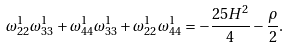<formula> <loc_0><loc_0><loc_500><loc_500>\omega _ { 2 2 } ^ { 1 } \omega _ { 3 3 } ^ { 1 } + \omega _ { 4 4 } ^ { 1 } \omega _ { 3 3 } ^ { 1 } + \omega _ { 2 2 } ^ { 1 } \omega _ { 4 4 } ^ { 1 } = - \frac { 2 5 H ^ { 2 } } { 4 } - \frac { \rho } { 2 } .</formula> 